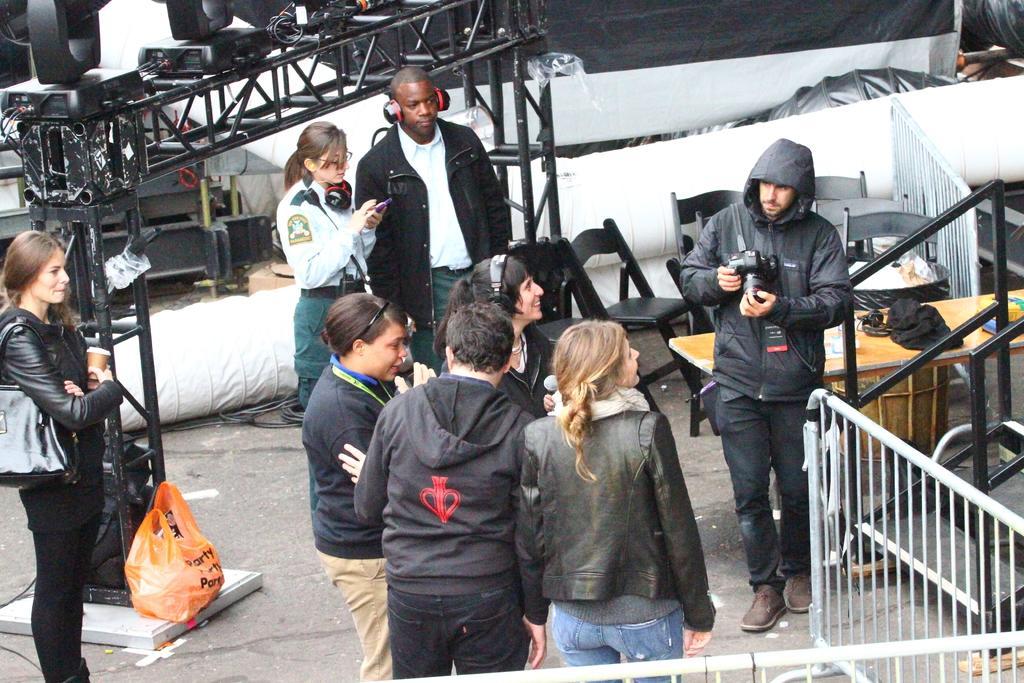How would you summarize this image in a sentence or two? In this picture I can observe some people standing on the land. There are men and women in this picture. On the right side I can observe a railing and chairs in front of a table. 